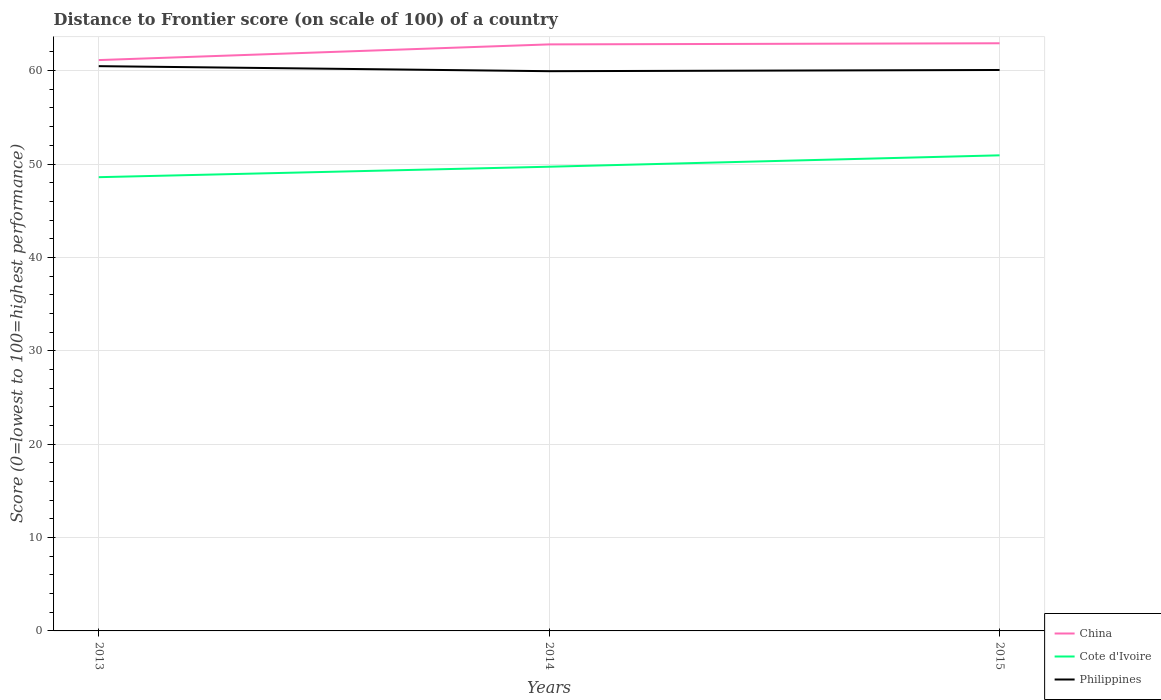Does the line corresponding to China intersect with the line corresponding to Cote d'Ivoire?
Offer a very short reply. No. Across all years, what is the maximum distance to frontier score of in Cote d'Ivoire?
Offer a terse response. 48.59. What is the total distance to frontier score of in China in the graph?
Keep it short and to the point. -1.68. What is the difference between the highest and the second highest distance to frontier score of in Philippines?
Provide a succinct answer. 0.54. What is the difference between the highest and the lowest distance to frontier score of in Cote d'Ivoire?
Give a very brief answer. 1. Is the distance to frontier score of in Cote d'Ivoire strictly greater than the distance to frontier score of in China over the years?
Provide a succinct answer. Yes. How many lines are there?
Give a very brief answer. 3. Does the graph contain any zero values?
Provide a succinct answer. No. Where does the legend appear in the graph?
Keep it short and to the point. Bottom right. How many legend labels are there?
Provide a short and direct response. 3. How are the legend labels stacked?
Your response must be concise. Vertical. What is the title of the graph?
Provide a short and direct response. Distance to Frontier score (on scale of 100) of a country. Does "Indonesia" appear as one of the legend labels in the graph?
Your response must be concise. No. What is the label or title of the Y-axis?
Your answer should be very brief. Score (0=lowest to 100=highest performance). What is the Score (0=lowest to 100=highest performance) in China in 2013?
Offer a very short reply. 61.13. What is the Score (0=lowest to 100=highest performance) of Cote d'Ivoire in 2013?
Keep it short and to the point. 48.59. What is the Score (0=lowest to 100=highest performance) in Philippines in 2013?
Your answer should be compact. 60.48. What is the Score (0=lowest to 100=highest performance) in China in 2014?
Make the answer very short. 62.81. What is the Score (0=lowest to 100=highest performance) in Cote d'Ivoire in 2014?
Make the answer very short. 49.71. What is the Score (0=lowest to 100=highest performance) of Philippines in 2014?
Provide a succinct answer. 59.94. What is the Score (0=lowest to 100=highest performance) in China in 2015?
Offer a terse response. 62.93. What is the Score (0=lowest to 100=highest performance) in Cote d'Ivoire in 2015?
Provide a succinct answer. 50.93. What is the Score (0=lowest to 100=highest performance) in Philippines in 2015?
Keep it short and to the point. 60.07. Across all years, what is the maximum Score (0=lowest to 100=highest performance) of China?
Give a very brief answer. 62.93. Across all years, what is the maximum Score (0=lowest to 100=highest performance) of Cote d'Ivoire?
Provide a short and direct response. 50.93. Across all years, what is the maximum Score (0=lowest to 100=highest performance) of Philippines?
Provide a succinct answer. 60.48. Across all years, what is the minimum Score (0=lowest to 100=highest performance) in China?
Keep it short and to the point. 61.13. Across all years, what is the minimum Score (0=lowest to 100=highest performance) of Cote d'Ivoire?
Give a very brief answer. 48.59. Across all years, what is the minimum Score (0=lowest to 100=highest performance) in Philippines?
Your response must be concise. 59.94. What is the total Score (0=lowest to 100=highest performance) in China in the graph?
Your answer should be very brief. 186.87. What is the total Score (0=lowest to 100=highest performance) in Cote d'Ivoire in the graph?
Provide a short and direct response. 149.23. What is the total Score (0=lowest to 100=highest performance) in Philippines in the graph?
Make the answer very short. 180.49. What is the difference between the Score (0=lowest to 100=highest performance) of China in 2013 and that in 2014?
Provide a short and direct response. -1.68. What is the difference between the Score (0=lowest to 100=highest performance) of Cote d'Ivoire in 2013 and that in 2014?
Provide a succinct answer. -1.12. What is the difference between the Score (0=lowest to 100=highest performance) in Philippines in 2013 and that in 2014?
Ensure brevity in your answer.  0.54. What is the difference between the Score (0=lowest to 100=highest performance) of Cote d'Ivoire in 2013 and that in 2015?
Give a very brief answer. -2.34. What is the difference between the Score (0=lowest to 100=highest performance) in Philippines in 2013 and that in 2015?
Your answer should be compact. 0.41. What is the difference between the Score (0=lowest to 100=highest performance) of China in 2014 and that in 2015?
Give a very brief answer. -0.12. What is the difference between the Score (0=lowest to 100=highest performance) of Cote d'Ivoire in 2014 and that in 2015?
Ensure brevity in your answer.  -1.22. What is the difference between the Score (0=lowest to 100=highest performance) of Philippines in 2014 and that in 2015?
Your answer should be compact. -0.13. What is the difference between the Score (0=lowest to 100=highest performance) of China in 2013 and the Score (0=lowest to 100=highest performance) of Cote d'Ivoire in 2014?
Offer a terse response. 11.42. What is the difference between the Score (0=lowest to 100=highest performance) of China in 2013 and the Score (0=lowest to 100=highest performance) of Philippines in 2014?
Provide a succinct answer. 1.19. What is the difference between the Score (0=lowest to 100=highest performance) of Cote d'Ivoire in 2013 and the Score (0=lowest to 100=highest performance) of Philippines in 2014?
Ensure brevity in your answer.  -11.35. What is the difference between the Score (0=lowest to 100=highest performance) of China in 2013 and the Score (0=lowest to 100=highest performance) of Cote d'Ivoire in 2015?
Your response must be concise. 10.2. What is the difference between the Score (0=lowest to 100=highest performance) of China in 2013 and the Score (0=lowest to 100=highest performance) of Philippines in 2015?
Provide a succinct answer. 1.06. What is the difference between the Score (0=lowest to 100=highest performance) of Cote d'Ivoire in 2013 and the Score (0=lowest to 100=highest performance) of Philippines in 2015?
Give a very brief answer. -11.48. What is the difference between the Score (0=lowest to 100=highest performance) of China in 2014 and the Score (0=lowest to 100=highest performance) of Cote d'Ivoire in 2015?
Keep it short and to the point. 11.88. What is the difference between the Score (0=lowest to 100=highest performance) in China in 2014 and the Score (0=lowest to 100=highest performance) in Philippines in 2015?
Offer a very short reply. 2.74. What is the difference between the Score (0=lowest to 100=highest performance) of Cote d'Ivoire in 2014 and the Score (0=lowest to 100=highest performance) of Philippines in 2015?
Make the answer very short. -10.36. What is the average Score (0=lowest to 100=highest performance) in China per year?
Your response must be concise. 62.29. What is the average Score (0=lowest to 100=highest performance) of Cote d'Ivoire per year?
Ensure brevity in your answer.  49.74. What is the average Score (0=lowest to 100=highest performance) in Philippines per year?
Your answer should be very brief. 60.16. In the year 2013, what is the difference between the Score (0=lowest to 100=highest performance) in China and Score (0=lowest to 100=highest performance) in Cote d'Ivoire?
Make the answer very short. 12.54. In the year 2013, what is the difference between the Score (0=lowest to 100=highest performance) in China and Score (0=lowest to 100=highest performance) in Philippines?
Ensure brevity in your answer.  0.65. In the year 2013, what is the difference between the Score (0=lowest to 100=highest performance) in Cote d'Ivoire and Score (0=lowest to 100=highest performance) in Philippines?
Make the answer very short. -11.89. In the year 2014, what is the difference between the Score (0=lowest to 100=highest performance) in China and Score (0=lowest to 100=highest performance) in Philippines?
Provide a short and direct response. 2.87. In the year 2014, what is the difference between the Score (0=lowest to 100=highest performance) of Cote d'Ivoire and Score (0=lowest to 100=highest performance) of Philippines?
Your answer should be very brief. -10.23. In the year 2015, what is the difference between the Score (0=lowest to 100=highest performance) in China and Score (0=lowest to 100=highest performance) in Philippines?
Provide a succinct answer. 2.86. In the year 2015, what is the difference between the Score (0=lowest to 100=highest performance) in Cote d'Ivoire and Score (0=lowest to 100=highest performance) in Philippines?
Your answer should be very brief. -9.14. What is the ratio of the Score (0=lowest to 100=highest performance) in China in 2013 to that in 2014?
Provide a short and direct response. 0.97. What is the ratio of the Score (0=lowest to 100=highest performance) of Cote d'Ivoire in 2013 to that in 2014?
Provide a short and direct response. 0.98. What is the ratio of the Score (0=lowest to 100=highest performance) in China in 2013 to that in 2015?
Your response must be concise. 0.97. What is the ratio of the Score (0=lowest to 100=highest performance) in Cote d'Ivoire in 2013 to that in 2015?
Ensure brevity in your answer.  0.95. What is the ratio of the Score (0=lowest to 100=highest performance) in Philippines in 2013 to that in 2015?
Ensure brevity in your answer.  1.01. What is the ratio of the Score (0=lowest to 100=highest performance) in Cote d'Ivoire in 2014 to that in 2015?
Provide a short and direct response. 0.98. What is the difference between the highest and the second highest Score (0=lowest to 100=highest performance) of China?
Give a very brief answer. 0.12. What is the difference between the highest and the second highest Score (0=lowest to 100=highest performance) in Cote d'Ivoire?
Give a very brief answer. 1.22. What is the difference between the highest and the second highest Score (0=lowest to 100=highest performance) of Philippines?
Offer a very short reply. 0.41. What is the difference between the highest and the lowest Score (0=lowest to 100=highest performance) in China?
Make the answer very short. 1.8. What is the difference between the highest and the lowest Score (0=lowest to 100=highest performance) of Cote d'Ivoire?
Your answer should be very brief. 2.34. What is the difference between the highest and the lowest Score (0=lowest to 100=highest performance) in Philippines?
Keep it short and to the point. 0.54. 